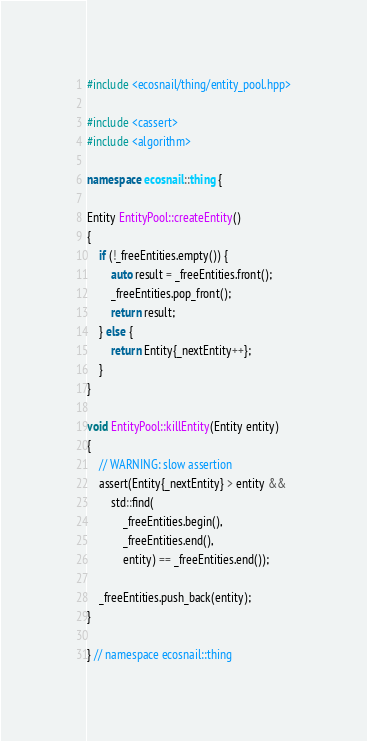<code> <loc_0><loc_0><loc_500><loc_500><_C++_>#include <ecosnail/thing/entity_pool.hpp>

#include <cassert>
#include <algorithm>

namespace ecosnail::thing {

Entity EntityPool::createEntity()
{
    if (!_freeEntities.empty()) {
        auto result = _freeEntities.front();
        _freeEntities.pop_front();
        return result;
    } else {
        return Entity{_nextEntity++};
    }
}

void EntityPool::killEntity(Entity entity)
{
    // WARNING: slow assertion
    assert(Entity{_nextEntity} > entity &&
        std::find(
            _freeEntities.begin(),
            _freeEntities.end(),
            entity) == _freeEntities.end());

    _freeEntities.push_back(entity);
}

} // namespace ecosnail::thing
</code> 